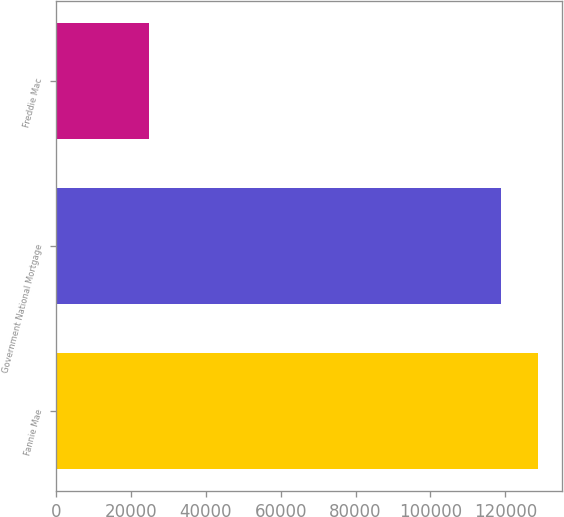Convert chart. <chart><loc_0><loc_0><loc_500><loc_500><bar_chart><fcel>Fannie Mae<fcel>Government National Mortgage<fcel>Freddie Mac<nl><fcel>128590<fcel>118700<fcel>24908<nl></chart> 